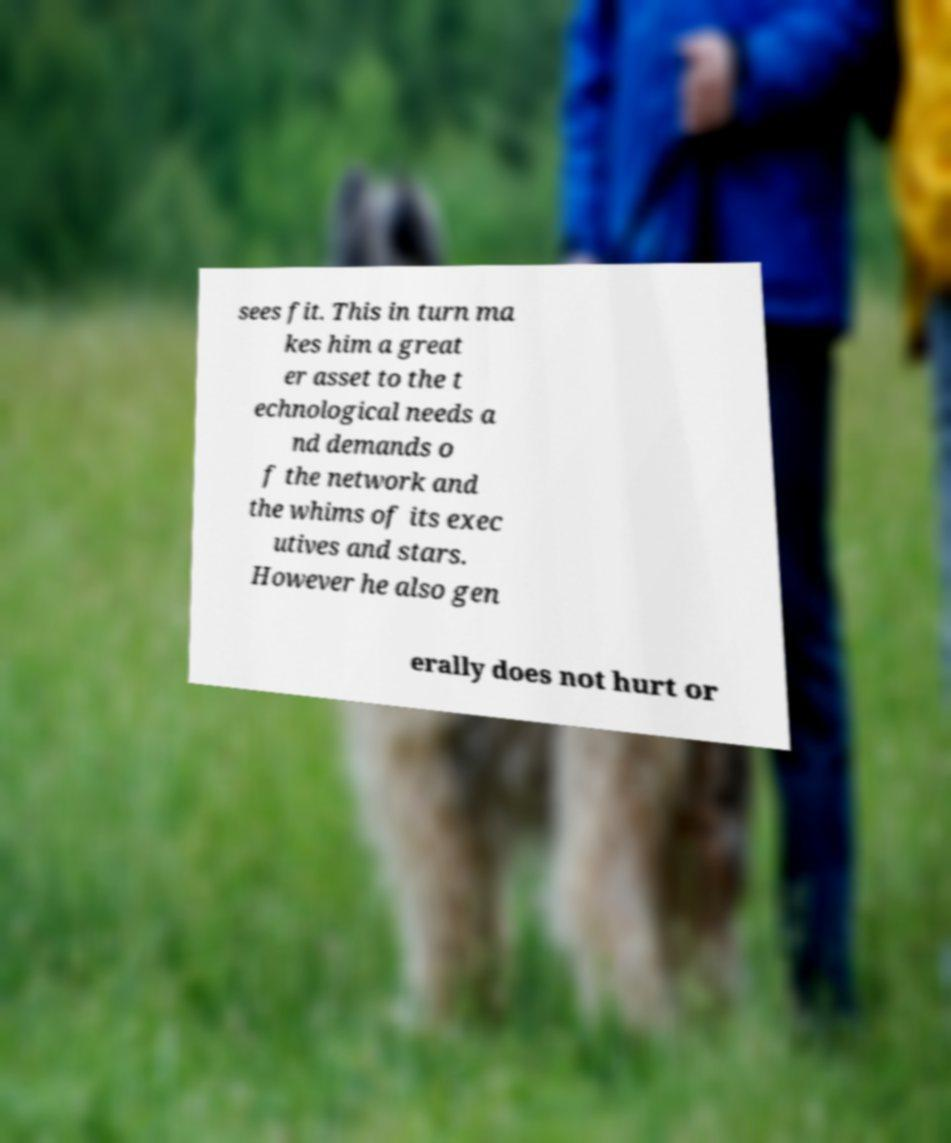There's text embedded in this image that I need extracted. Can you transcribe it verbatim? sees fit. This in turn ma kes him a great er asset to the t echnological needs a nd demands o f the network and the whims of its exec utives and stars. However he also gen erally does not hurt or 